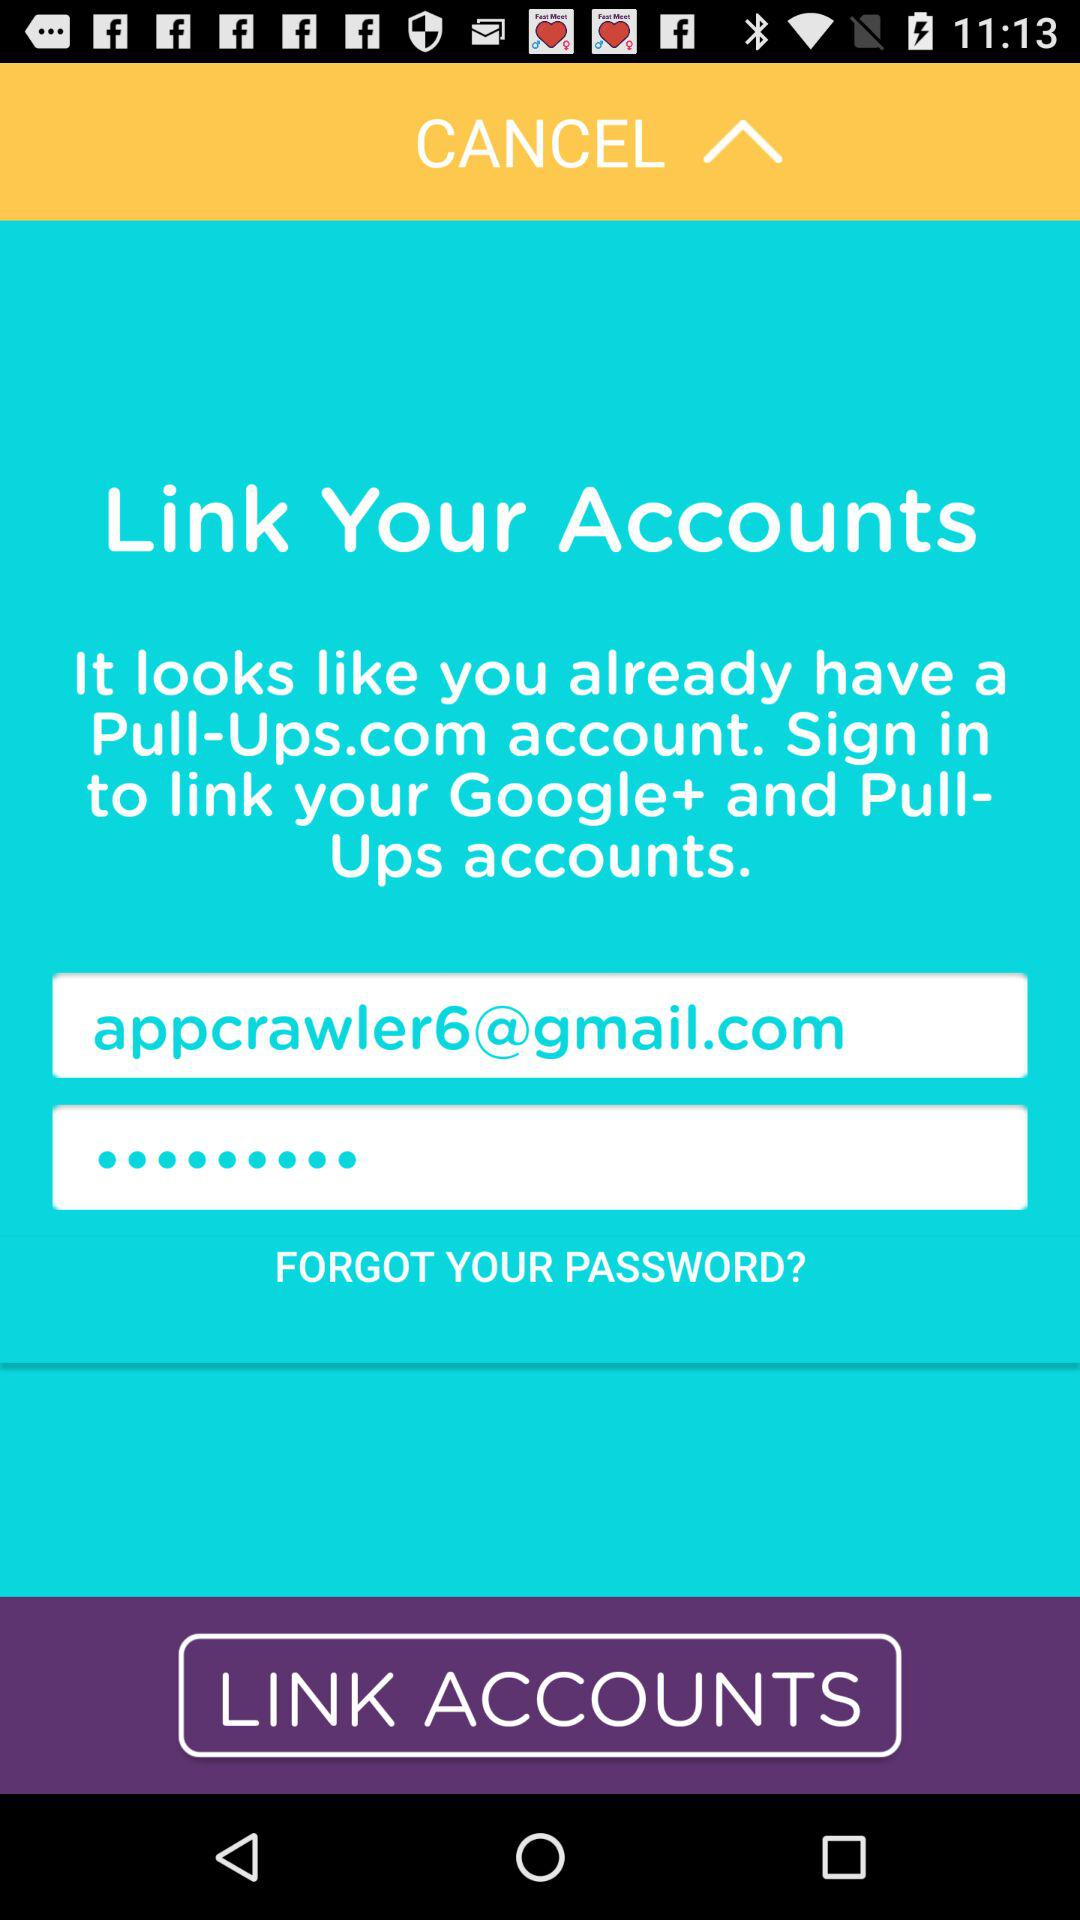How many text inputs have the text 'appcrawler6@gmail.com'?
Answer the question using a single word or phrase. 1 